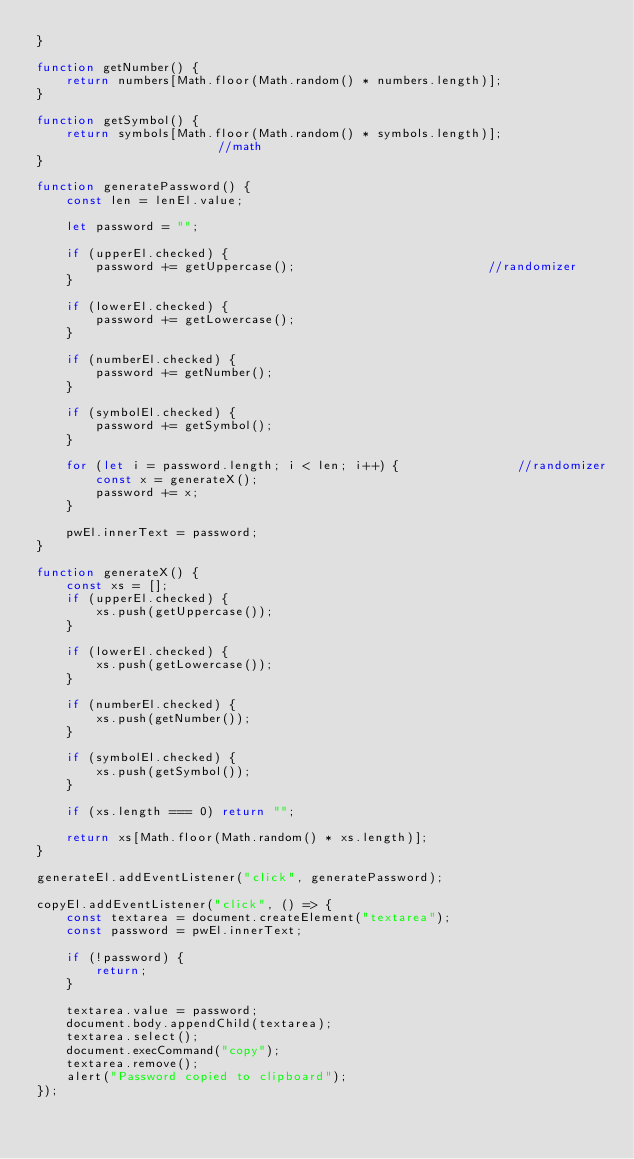Convert code to text. <code><loc_0><loc_0><loc_500><loc_500><_JavaScript_>}

function getNumber() {
    return numbers[Math.floor(Math.random() * numbers.length)];
}

function getSymbol() {
    return symbols[Math.floor(Math.random() * symbols.length)];                 //math 
}

function generatePassword() {
    const len = lenEl.value;

    let password = "";

    if (upperEl.checked) {
        password += getUppercase();                          //randomizer
    }

    if (lowerEl.checked) {
        password += getLowercase();
    }

    if (numberEl.checked) {
        password += getNumber();
    }

    if (symbolEl.checked) {
        password += getSymbol();
    }

    for (let i = password.length; i < len; i++) {                //randomizer
        const x = generateX();
        password += x;
    }

    pwEl.innerText = password;
}

function generateX() {
    const xs = [];
    if (upperEl.checked) {
        xs.push(getUppercase());
    }

    if (lowerEl.checked) {
        xs.push(getLowercase());
    }

    if (numberEl.checked) {
        xs.push(getNumber());
    }

    if (symbolEl.checked) {
        xs.push(getSymbol());
    }

    if (xs.length === 0) return "";

    return xs[Math.floor(Math.random() * xs.length)];
}

generateEl.addEventListener("click", generatePassword);

copyEl.addEventListener("click", () => {
    const textarea = document.createElement("textarea");
    const password = pwEl.innerText;

    if (!password) {
        return;
    }

    textarea.value = password;
    document.body.appendChild(textarea);
    textarea.select();
    document.execCommand("copy");
    textarea.remove();
    alert("Password copied to clipboard");
});
</code> 